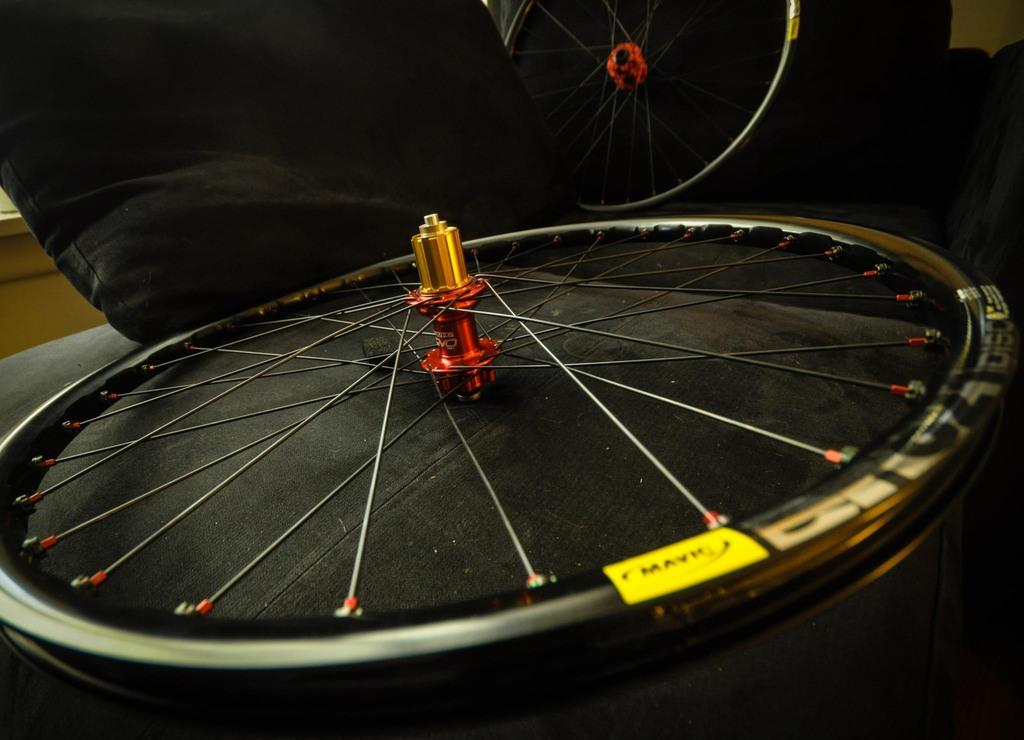What can be seen on the wooden surface in the image? There is a wheel on a wooden surface in the image. Are there any other wheels visible in the image? Yes, there is another wheel in the background of the image. What is the color of the cloth at the top of the image? The cloth at the top of the image is black. What type of furniture can be seen in the background of the image? There is a table in the background of the image. What type of twig is being used to stir the cabbage in the image? There is no cabbage or twig present in the image. 